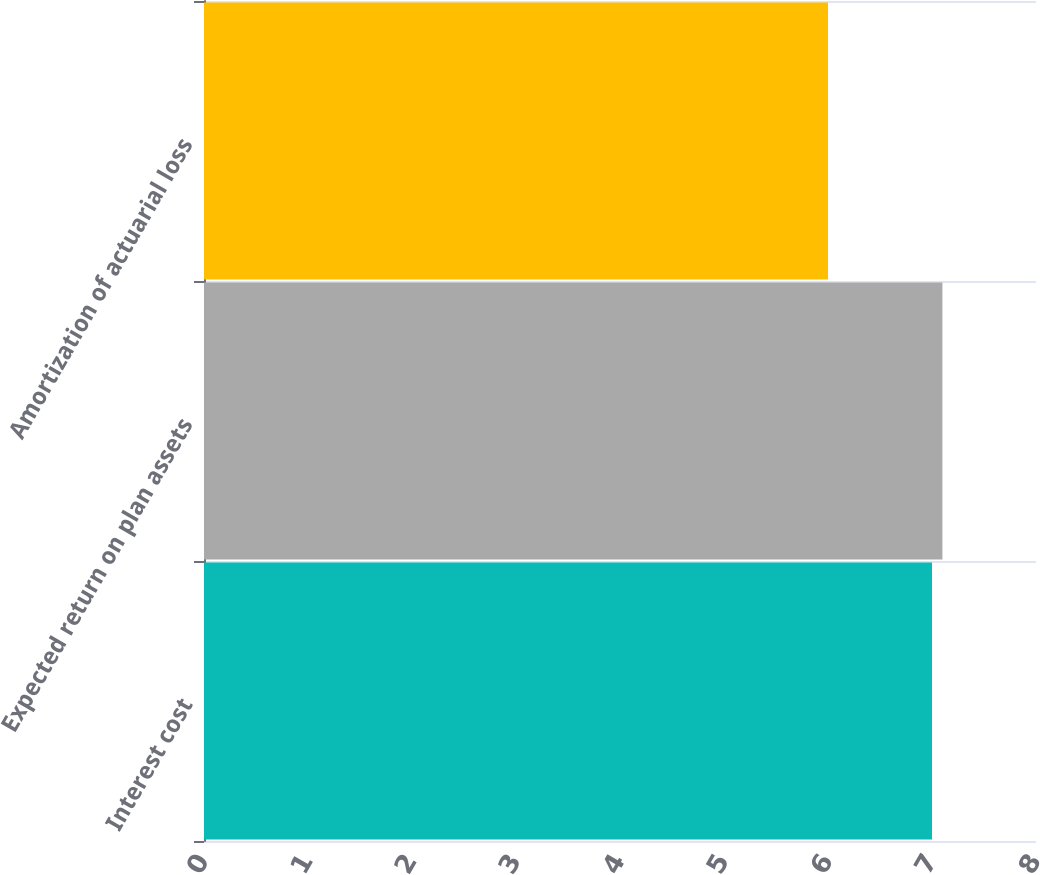Convert chart. <chart><loc_0><loc_0><loc_500><loc_500><bar_chart><fcel>Interest cost<fcel>Expected return on plan assets<fcel>Amortization of actuarial loss<nl><fcel>7<fcel>7.1<fcel>6<nl></chart> 